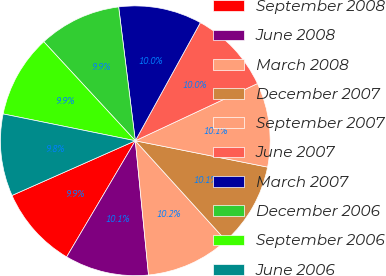<chart> <loc_0><loc_0><loc_500><loc_500><pie_chart><fcel>September 2008<fcel>June 2008<fcel>March 2008<fcel>December 2007<fcel>September 2007<fcel>June 2007<fcel>March 2007<fcel>December 2006<fcel>September 2006<fcel>June 2006<nl><fcel>9.86%<fcel>10.06%<fcel>10.17%<fcel>10.14%<fcel>10.1%<fcel>10.02%<fcel>9.98%<fcel>9.9%<fcel>9.94%<fcel>9.83%<nl></chart> 